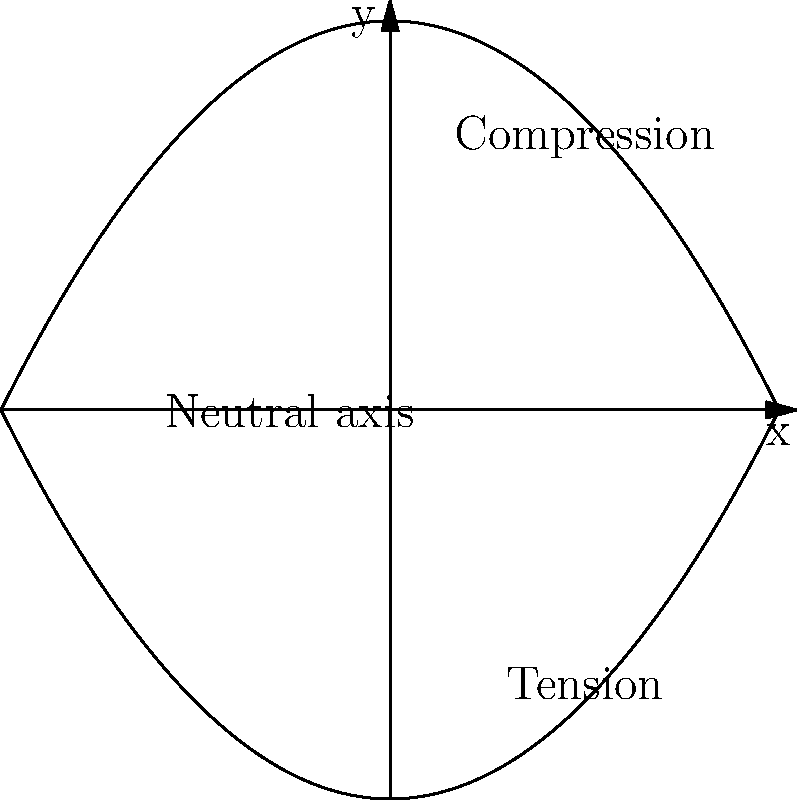In the context of load-bearing walls, the image represents a visual narrative of stress distribution. How does this graphical representation relate to the concept of a "neutral axis" in structural engineering, and what story does it tell about the forces at play? To understand this visual representation of stress distribution, let's break it down step-by-step:

1. The graph shows two curved lines symmetrical about the x-axis, forming a shape similar to an hourglass.

2. The vertical y-axis represents the cross-section of a load-bearing wall, with the top being the outer face and the bottom being the inner face.

3. The horizontal x-axis represents the stress magnitude, with positive values indicating compression and negative values indicating tension.

4. The upper curve represents the compression zone, where the material is being squeezed together.

5. The lower curve represents the tension zone, where the material is being pulled apart.

6. The dashed vertical line at x=0 represents the "neutral axis," a concept in structural engineering where the stress transitions from compression to tension.

7. At the neutral axis, the stress is zero, neither compression nor tension.

8. As we move away from the neutral axis in either direction, the stress increases, reaching maximum values at the outer edges of the wall.

This visual narrative tells the story of how forces distribute through a load-bearing wall. It shows that one side of the wall experiences compression while the other experiences tension, with a smooth transition between these states. This distribution of forces is crucial for the wall's stability and load-bearing capacity.

The concept of the neutral axis is particularly important, as it represents the point of transition and balance between the opposing forces, much like a fulcrum in a story's plot.
Answer: The neutral axis divides compression and tension zones, illustrating the balanced distribution of forces in a load-bearing wall. 